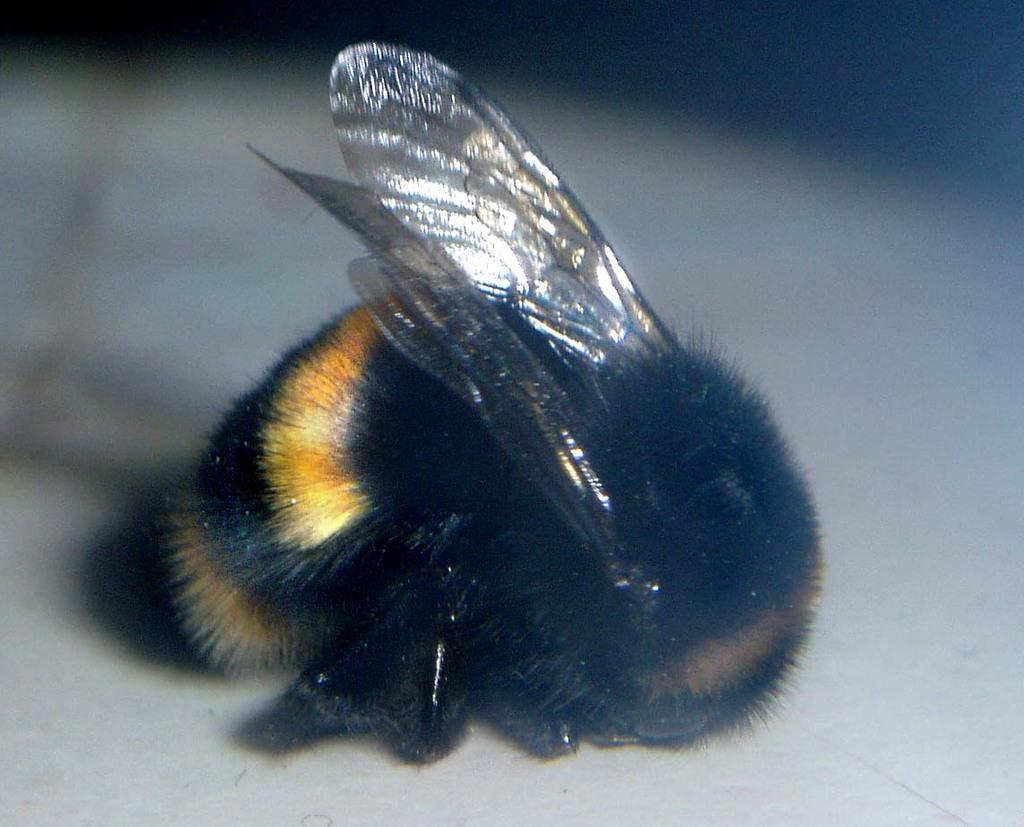What type of creature can be seen in the image? There is an insect in the image. Where is the insect located in the image? The insect is on a white path. What type of oven can be seen in the image? There is no oven present in the image. How many dogs are visible in the image? There are no dogs present in the image. 